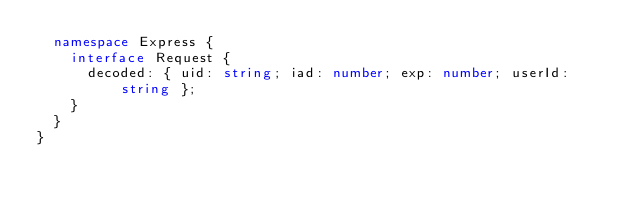<code> <loc_0><loc_0><loc_500><loc_500><_TypeScript_>  namespace Express {
    interface Request {
      decoded: { uid: string; iad: number; exp: number; userId: string };
    }
  }
}
</code> 